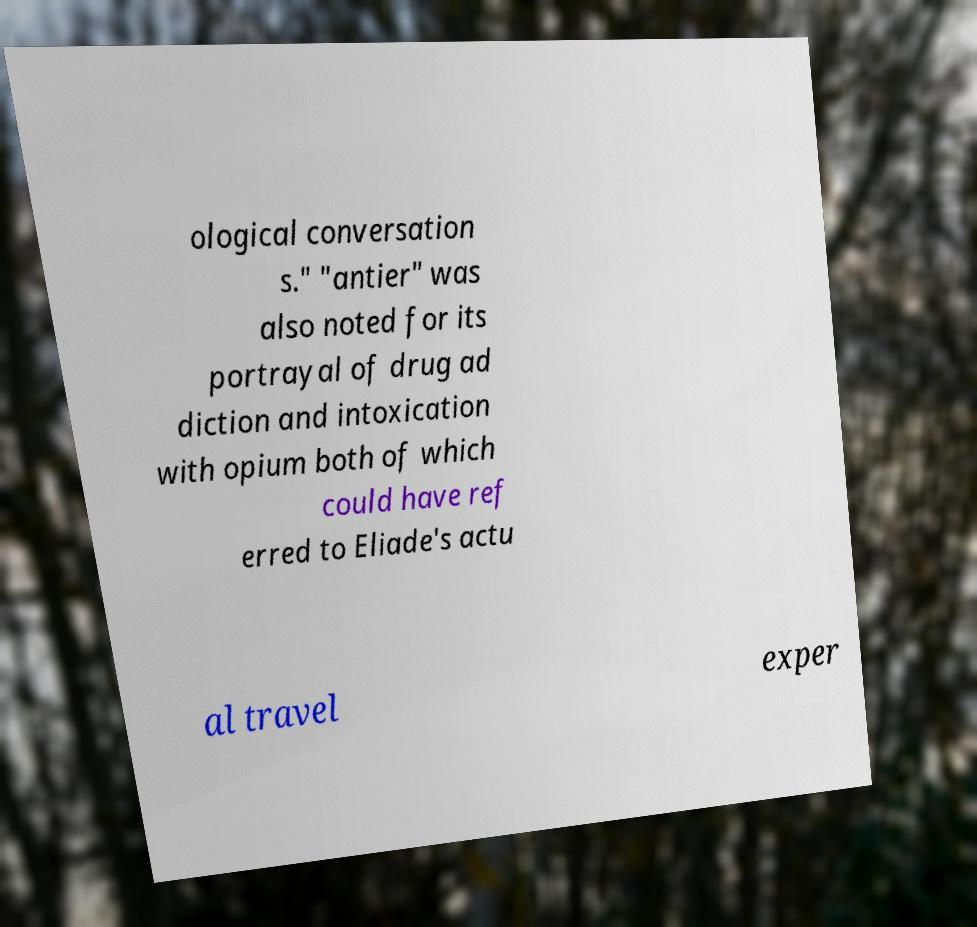Could you extract and type out the text from this image? ological conversation s." "antier" was also noted for its portrayal of drug ad diction and intoxication with opium both of which could have ref erred to Eliade's actu al travel exper 